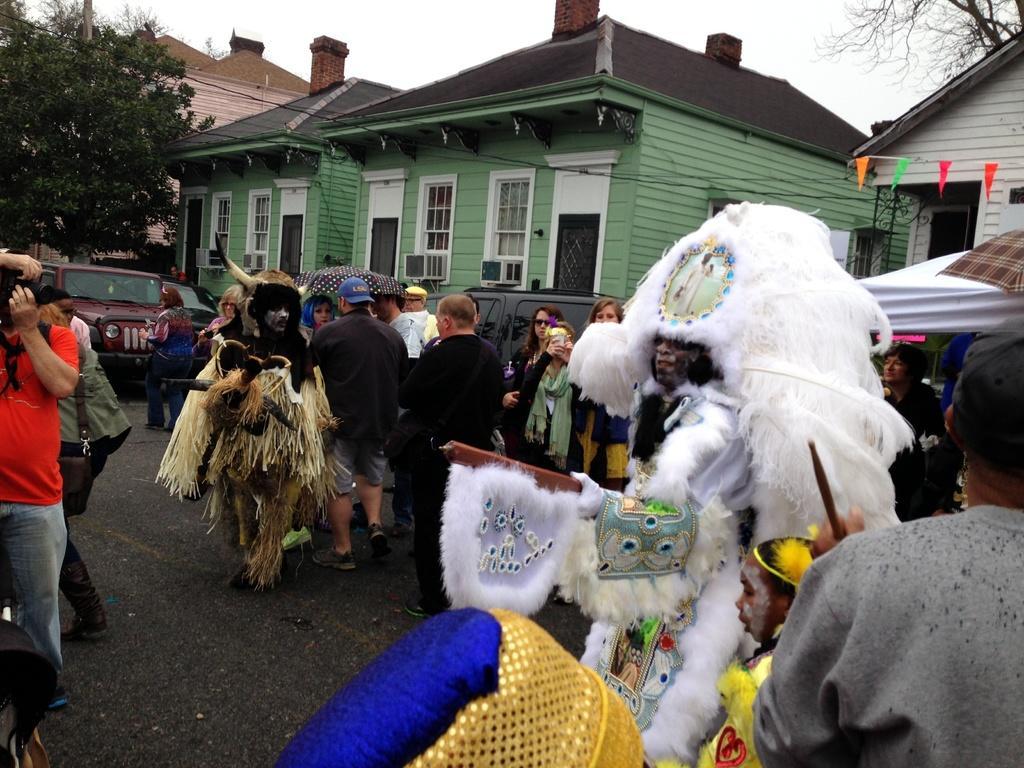Describe this image in one or two sentences. In this image we can see few houses and they are having many windows. There are few trees in the image. There are many people and few people are holding some objects in their hands. A person is taking a photo at the left side of the image. There is a sky in the image. 